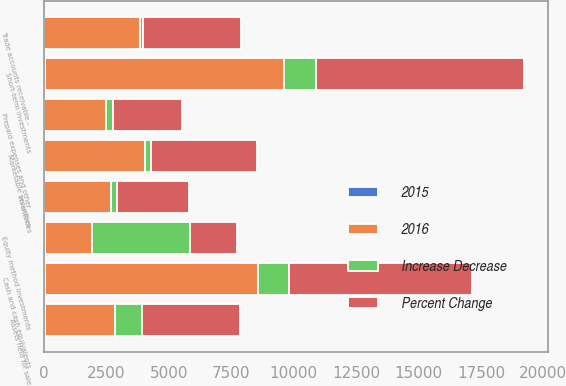Convert chart. <chart><loc_0><loc_0><loc_500><loc_500><stacked_bar_chart><ecel><fcel>Cash and cash equivalents<fcel>Short-term investments<fcel>Marketable securities<fcel>Trade accounts receivable -<fcel>Inventories<fcel>Prepaid expenses and other<fcel>Assets held for sale<fcel>Equity method investments<nl><fcel>2016<fcel>8555<fcel>9595<fcel>4051<fcel>3856<fcel>2675<fcel>2481<fcel>2797<fcel>1877<nl><fcel>Percent Change<fcel>7309<fcel>8322<fcel>4269<fcel>3941<fcel>2902<fcel>2752<fcel>3900<fcel>1877<nl><fcel>Increase Decrease<fcel>1246<fcel>1273<fcel>218<fcel>85<fcel>227<fcel>271<fcel>1103<fcel>3942<nl><fcel>2015<fcel>17<fcel>15<fcel>5<fcel>2<fcel>8<fcel>10<fcel>28<fcel>32<nl></chart> 